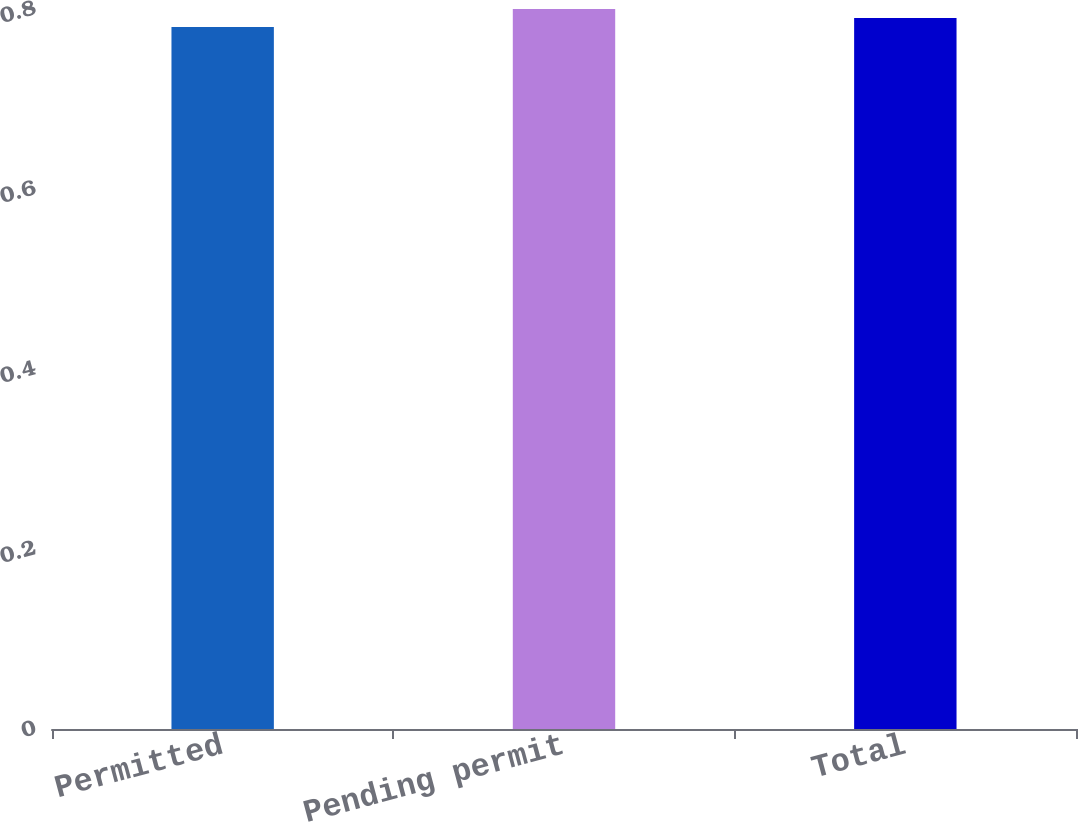<chart> <loc_0><loc_0><loc_500><loc_500><bar_chart><fcel>Permitted<fcel>Pending permit<fcel>Total<nl><fcel>0.78<fcel>0.8<fcel>0.79<nl></chart> 